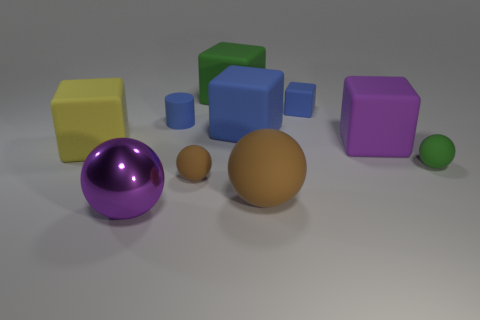Subtract all purple balls. How many blue cubes are left? 2 Subtract all large purple metal spheres. How many spheres are left? 3 Subtract all green spheres. How many spheres are left? 3 Subtract 3 cubes. How many cubes are left? 2 Subtract all blue balls. Subtract all purple cubes. How many balls are left? 4 Subtract all spheres. How many objects are left? 6 Subtract all big purple objects. Subtract all large yellow rubber things. How many objects are left? 7 Add 7 purple rubber things. How many purple rubber things are left? 8 Add 3 shiny spheres. How many shiny spheres exist? 4 Subtract 0 cyan balls. How many objects are left? 10 